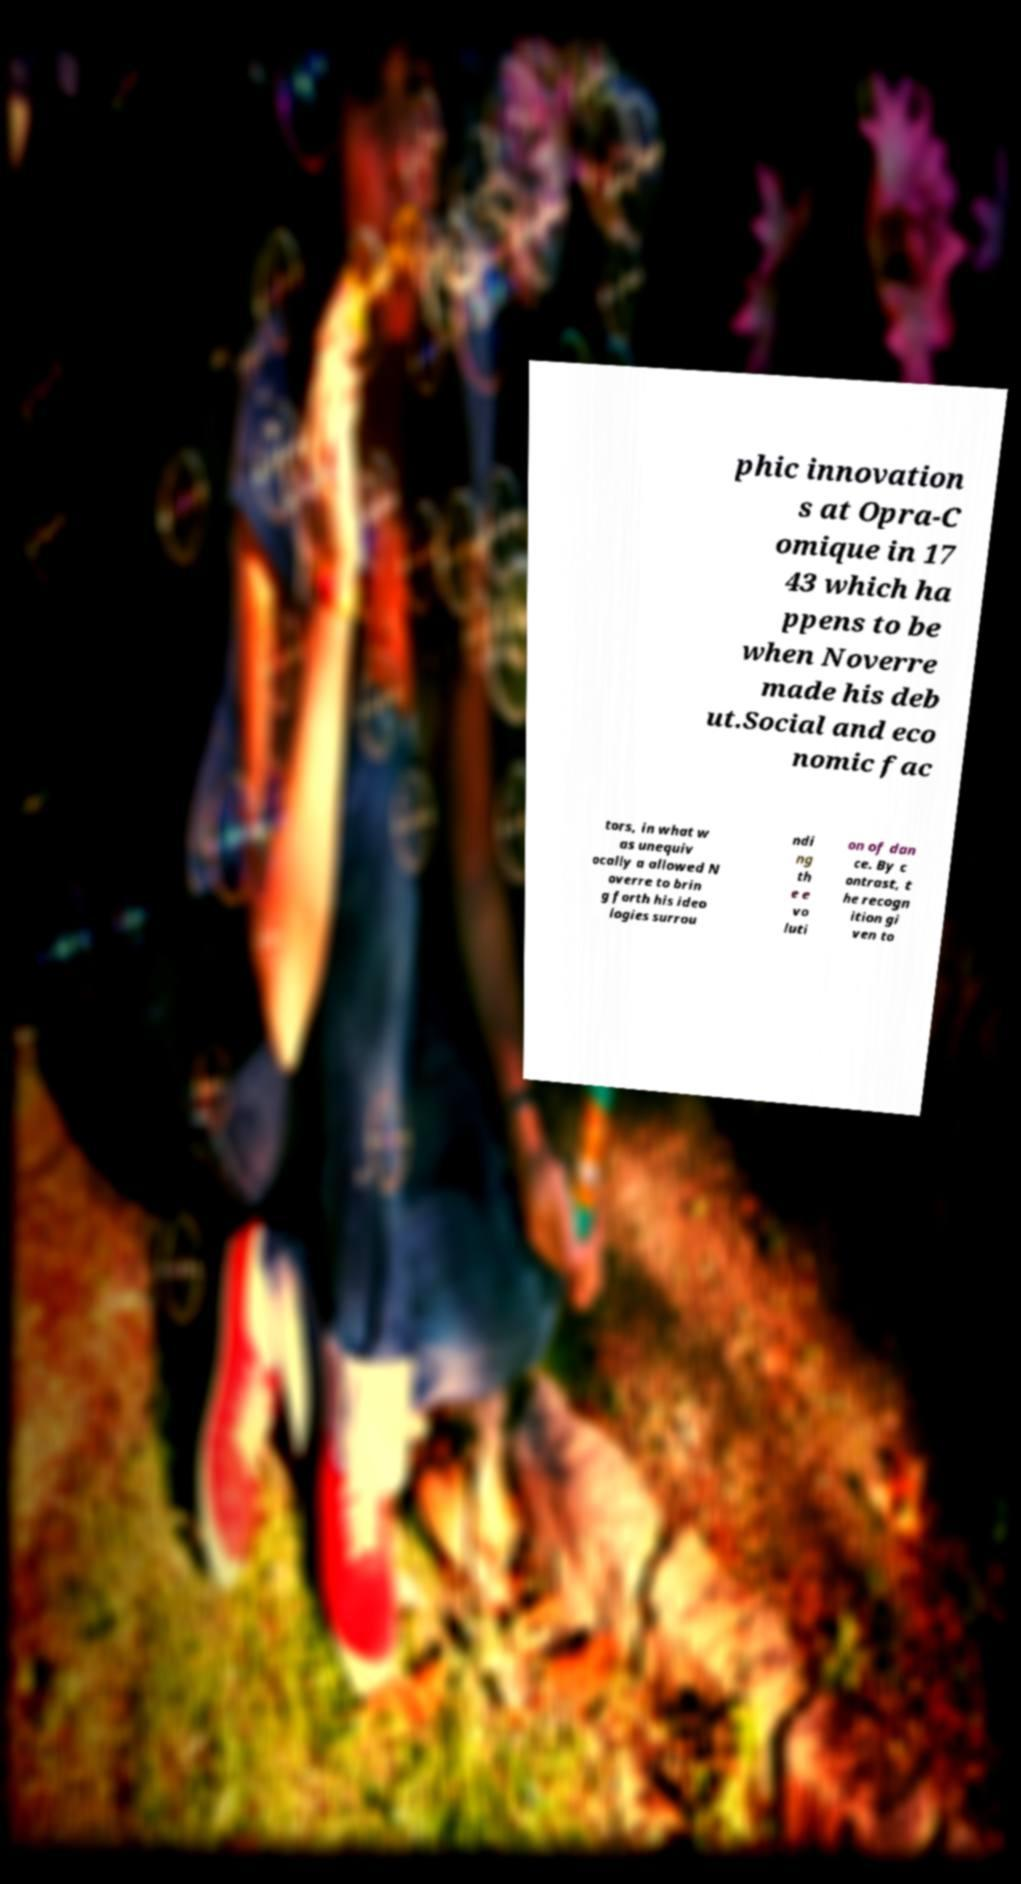Please identify and transcribe the text found in this image. phic innovation s at Opra-C omique in 17 43 which ha ppens to be when Noverre made his deb ut.Social and eco nomic fac tors, in what w as unequiv ocally a allowed N overre to brin g forth his ideo logies surrou ndi ng th e e vo luti on of dan ce. By c ontrast, t he recogn ition gi ven to 